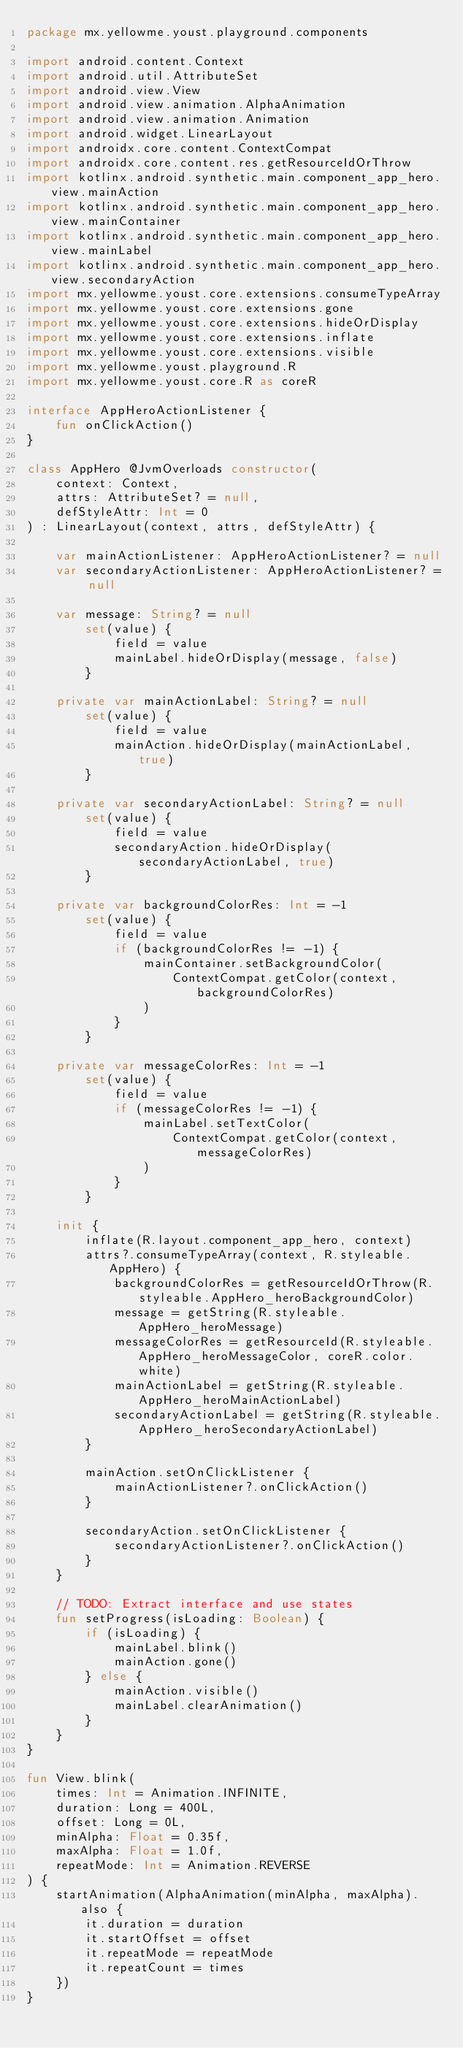<code> <loc_0><loc_0><loc_500><loc_500><_Kotlin_>package mx.yellowme.youst.playground.components

import android.content.Context
import android.util.AttributeSet
import android.view.View
import android.view.animation.AlphaAnimation
import android.view.animation.Animation
import android.widget.LinearLayout
import androidx.core.content.ContextCompat
import androidx.core.content.res.getResourceIdOrThrow
import kotlinx.android.synthetic.main.component_app_hero.view.mainAction
import kotlinx.android.synthetic.main.component_app_hero.view.mainContainer
import kotlinx.android.synthetic.main.component_app_hero.view.mainLabel
import kotlinx.android.synthetic.main.component_app_hero.view.secondaryAction
import mx.yellowme.youst.core.extensions.consumeTypeArray
import mx.yellowme.youst.core.extensions.gone
import mx.yellowme.youst.core.extensions.hideOrDisplay
import mx.yellowme.youst.core.extensions.inflate
import mx.yellowme.youst.core.extensions.visible
import mx.yellowme.youst.playground.R
import mx.yellowme.youst.core.R as coreR

interface AppHeroActionListener {
    fun onClickAction()
}

class AppHero @JvmOverloads constructor(
    context: Context,
    attrs: AttributeSet? = null,
    defStyleAttr: Int = 0
) : LinearLayout(context, attrs, defStyleAttr) {

    var mainActionListener: AppHeroActionListener? = null
    var secondaryActionListener: AppHeroActionListener? = null

    var message: String? = null
        set(value) {
            field = value
            mainLabel.hideOrDisplay(message, false)
        }

    private var mainActionLabel: String? = null
        set(value) {
            field = value
            mainAction.hideOrDisplay(mainActionLabel, true)
        }

    private var secondaryActionLabel: String? = null
        set(value) {
            field = value
            secondaryAction.hideOrDisplay(secondaryActionLabel, true)
        }

    private var backgroundColorRes: Int = -1
        set(value) {
            field = value
            if (backgroundColorRes != -1) {
                mainContainer.setBackgroundColor(
                    ContextCompat.getColor(context, backgroundColorRes)
                )
            }
        }

    private var messageColorRes: Int = -1
        set(value) {
            field = value
            if (messageColorRes != -1) {
                mainLabel.setTextColor(
                    ContextCompat.getColor(context, messageColorRes)
                )
            }
        }

    init {
        inflate(R.layout.component_app_hero, context)
        attrs?.consumeTypeArray(context, R.styleable.AppHero) {
            backgroundColorRes = getResourceIdOrThrow(R.styleable.AppHero_heroBackgroundColor)
            message = getString(R.styleable.AppHero_heroMessage)
            messageColorRes = getResourceId(R.styleable.AppHero_heroMessageColor, coreR.color.white)
            mainActionLabel = getString(R.styleable.AppHero_heroMainActionLabel)
            secondaryActionLabel = getString(R.styleable.AppHero_heroSecondaryActionLabel)
        }

        mainAction.setOnClickListener {
            mainActionListener?.onClickAction()
        }

        secondaryAction.setOnClickListener {
            secondaryActionListener?.onClickAction()
        }
    }

    // TODO: Extract interface and use states
    fun setProgress(isLoading: Boolean) {
        if (isLoading) {
            mainLabel.blink()
            mainAction.gone()
        } else {
            mainAction.visible()
            mainLabel.clearAnimation()
        }
    }
}

fun View.blink(
    times: Int = Animation.INFINITE,
    duration: Long = 400L,
    offset: Long = 0L,
    minAlpha: Float = 0.35f,
    maxAlpha: Float = 1.0f,
    repeatMode: Int = Animation.REVERSE
) {
    startAnimation(AlphaAnimation(minAlpha, maxAlpha).also {
        it.duration = duration
        it.startOffset = offset
        it.repeatMode = repeatMode
        it.repeatCount = times
    })
}
</code> 